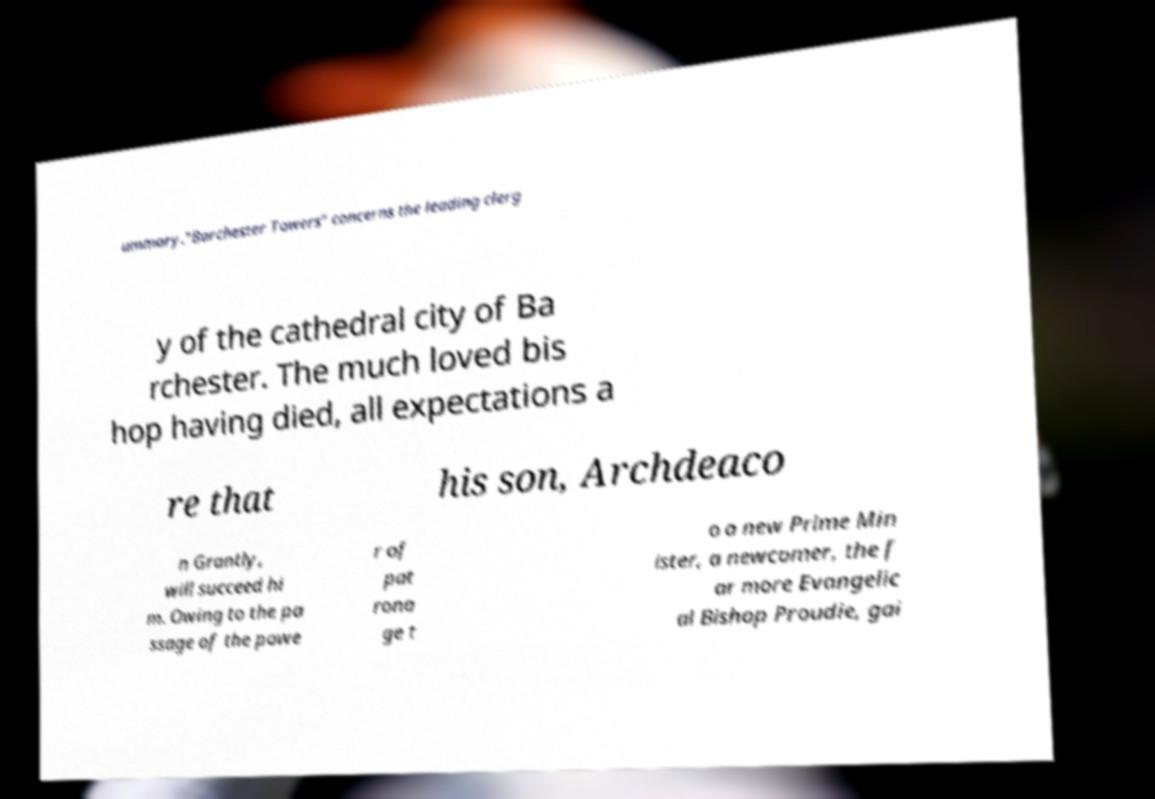There's text embedded in this image that I need extracted. Can you transcribe it verbatim? ummary."Barchester Towers" concerns the leading clerg y of the cathedral city of Ba rchester. The much loved bis hop having died, all expectations a re that his son, Archdeaco n Grantly, will succeed hi m. Owing to the pa ssage of the powe r of pat rona ge t o a new Prime Min ister, a newcomer, the f ar more Evangelic al Bishop Proudie, gai 